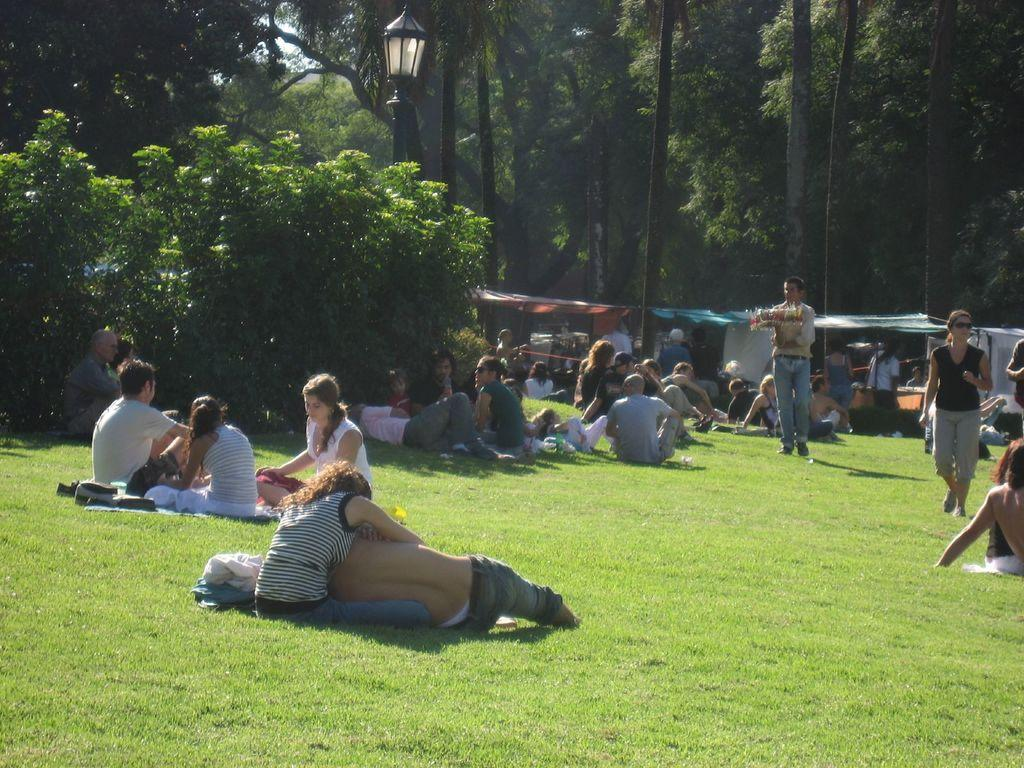How many people can be seen in the image? There are a few people in the image. What is visible beneath the people's feet? The ground is visible in the image. What type of vegetation is present in the image? There is grass, trees, and plants in the image. What structure can be seen in the image? There is a pole in the image. What type of temporary shelter is present in the image? There are tents in the image. What type of table is visible in the image? There is no table present in the image. How many mountains can be seen in the image? There are no mountains visible in the image. 